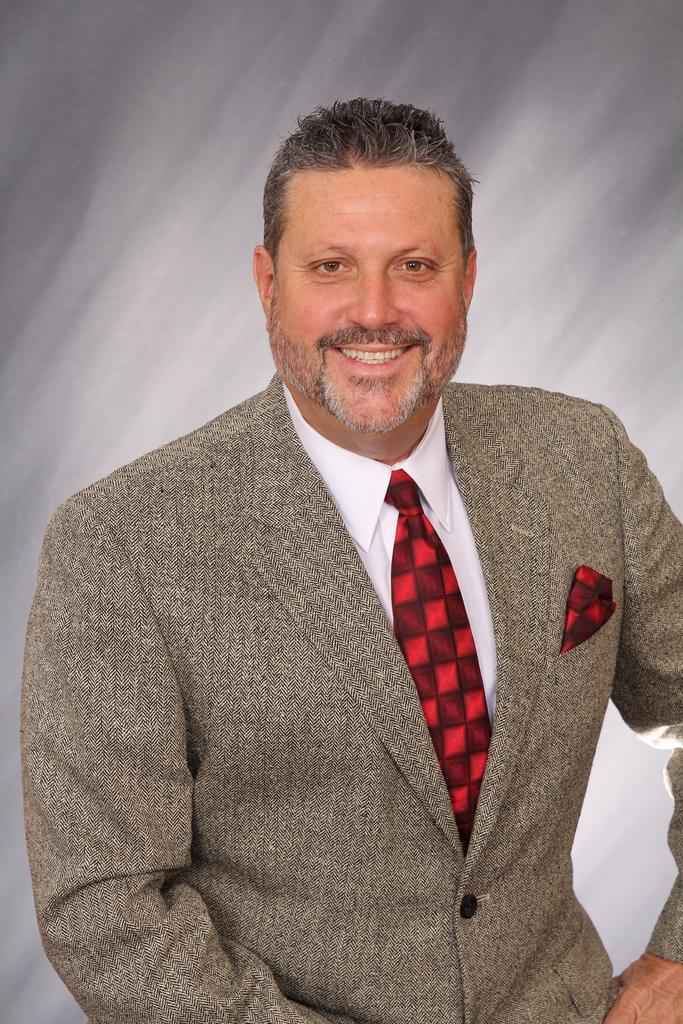What is the main subject of the image? There is a person in the image. What is the person wearing on their upper body? The person is wearing a cream color blazer, a white shirt, and a red color tie. What color is the background of the image? The background of the image is ash color. What type of lawyer is the person in the image? The text does not mention any profession or occupation for the person in the image, so we cannot determine if they are a lawyer or not. 